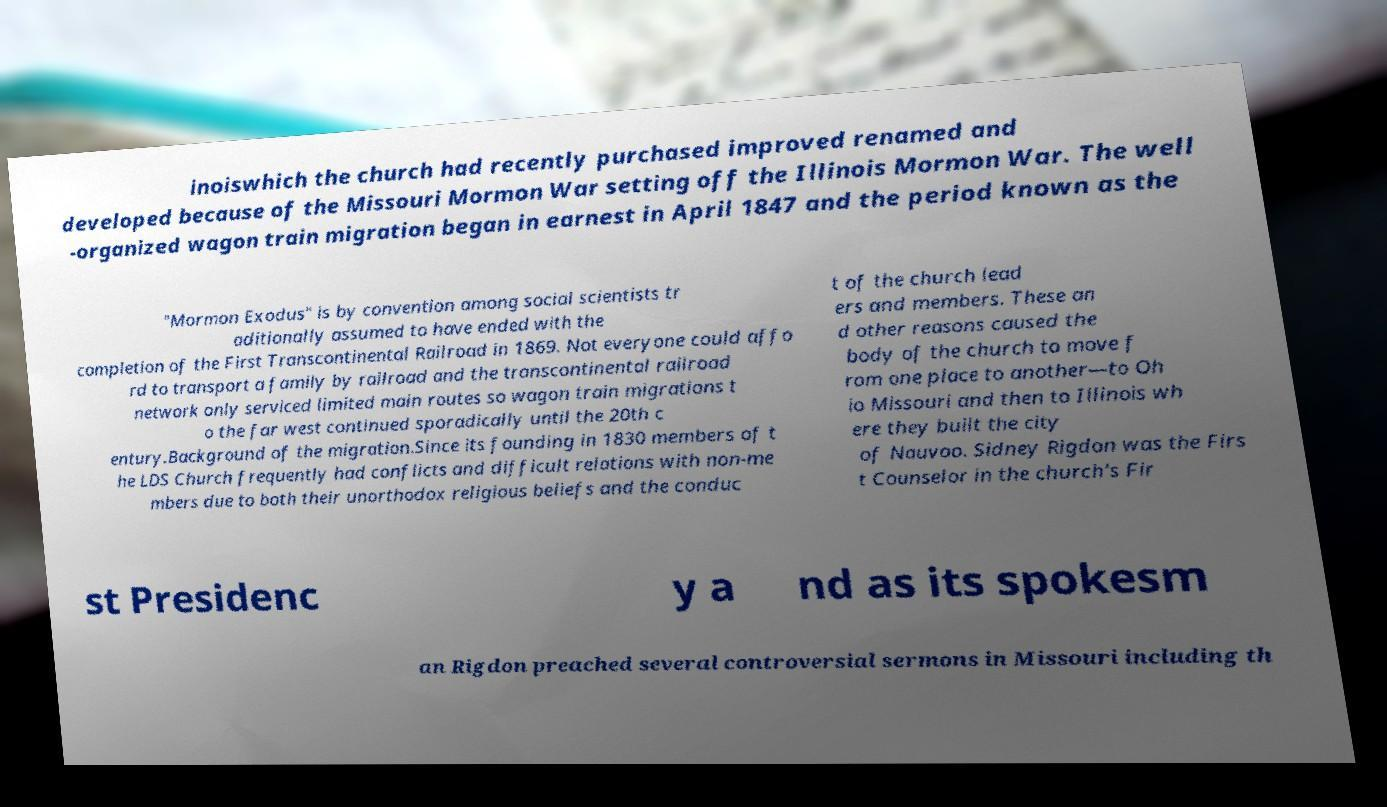There's text embedded in this image that I need extracted. Can you transcribe it verbatim? inoiswhich the church had recently purchased improved renamed and developed because of the Missouri Mormon War setting off the Illinois Mormon War. The well -organized wagon train migration began in earnest in April 1847 and the period known as the "Mormon Exodus" is by convention among social scientists tr aditionally assumed to have ended with the completion of the First Transcontinental Railroad in 1869. Not everyone could affo rd to transport a family by railroad and the transcontinental railroad network only serviced limited main routes so wagon train migrations t o the far west continued sporadically until the 20th c entury.Background of the migration.Since its founding in 1830 members of t he LDS Church frequently had conflicts and difficult relations with non-me mbers due to both their unorthodox religious beliefs and the conduc t of the church lead ers and members. These an d other reasons caused the body of the church to move f rom one place to another—to Oh io Missouri and then to Illinois wh ere they built the city of Nauvoo. Sidney Rigdon was the Firs t Counselor in the church's Fir st Presidenc y a nd as its spokesm an Rigdon preached several controversial sermons in Missouri including th 